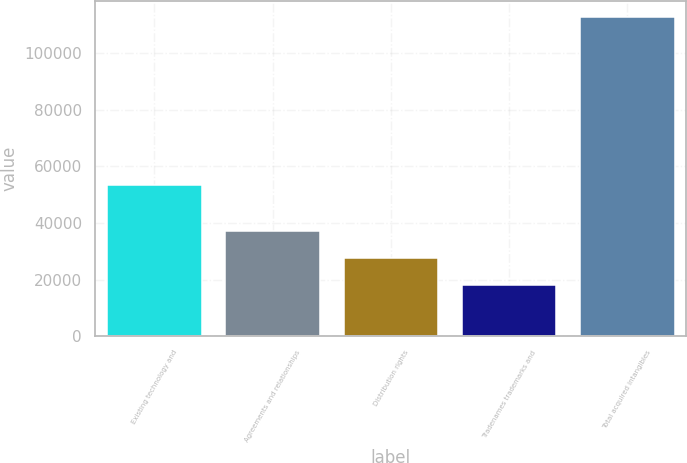<chart> <loc_0><loc_0><loc_500><loc_500><bar_chart><fcel>Existing technology and<fcel>Agreements and relationships<fcel>Distribution rights<fcel>Tradenames trademarks and<fcel>Total acquired intangibles<nl><fcel>53517<fcel>37168.4<fcel>27722.2<fcel>18276<fcel>112738<nl></chart> 